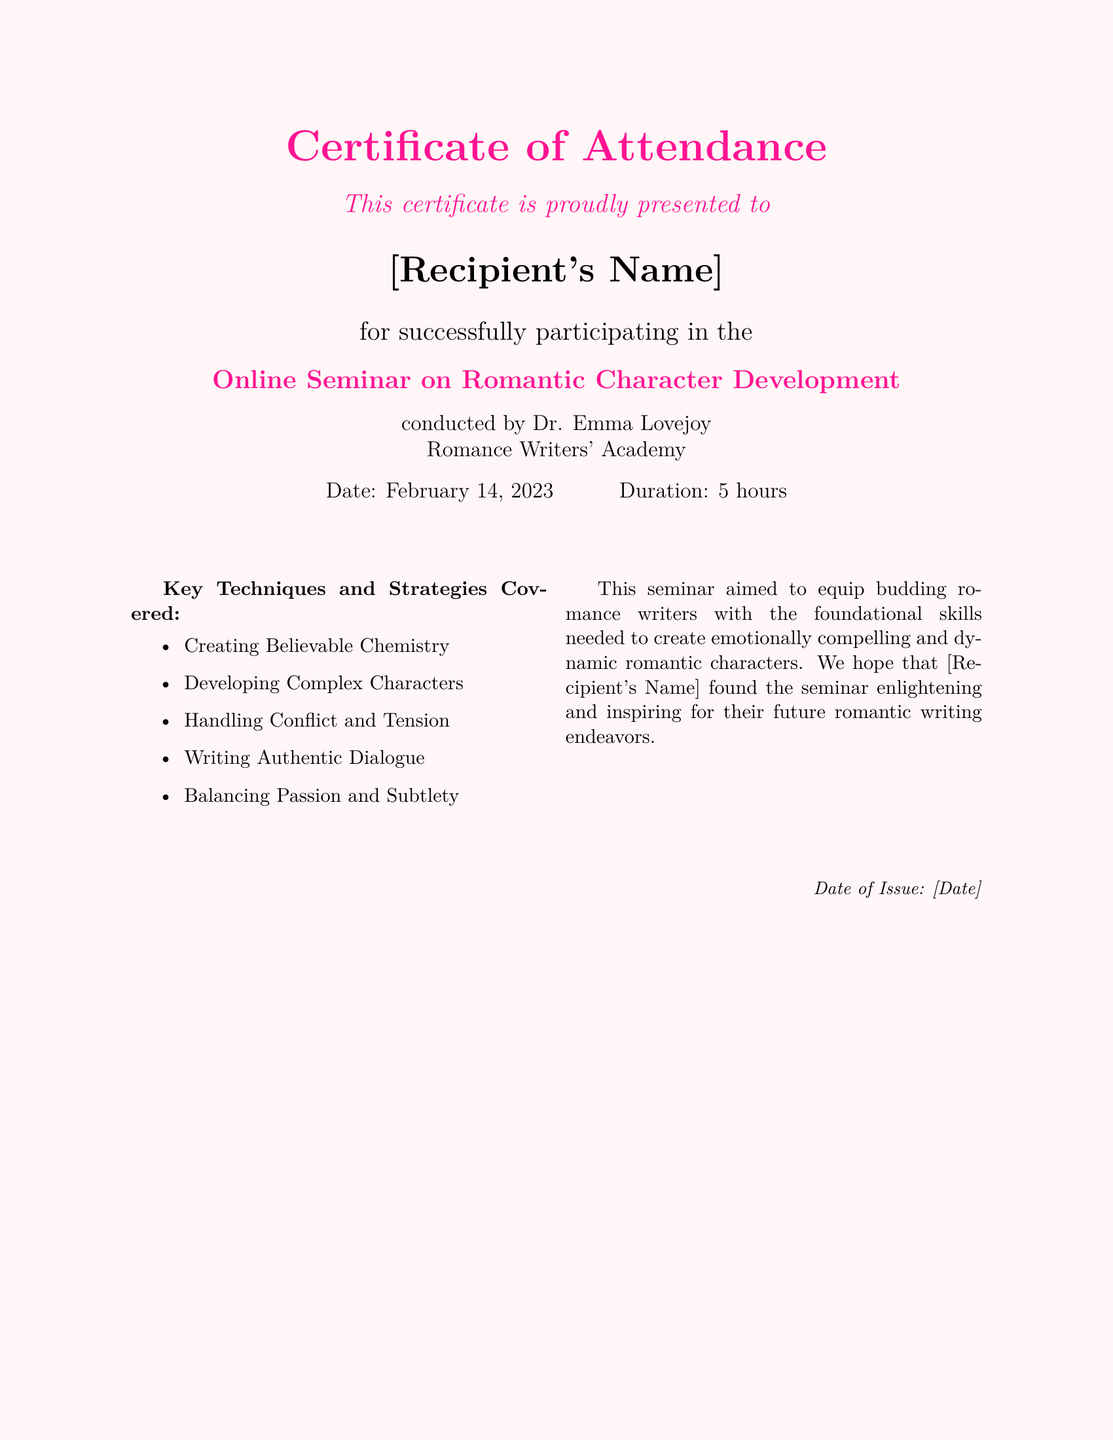What is the name of the seminar? The seminar's title is explicitly stated in the document as "Online Seminar on Romantic Character Development."
Answer: Online Seminar on Romantic Character Development Who conducted the seminar? The document specifies that the seminar was conducted by Dr. Emma Lovejoy.
Answer: Dr. Emma Lovejoy What is the date of the seminar? The document provides the specific date of the seminar, which is clearly indicated as February 14, 2023.
Answer: February 14, 2023 How long was the seminar? The document mentions that the duration of the seminar was 5 hours.
Answer: 5 hours What is one key technique covered in the seminar? The document lists several techniques, one of which is "Creating Believable Chemistry."
Answer: Creating Believable Chemistry What is the purpose of the seminar? The document states that the seminar aimed to equip budding romance writers with foundational skills.
Answer: To equip budding romance writers with foundational skills On what date was the certificate issued? The certificate has a placeholder for the issuance date, indicated as [Date] in the document.
Answer: [Date] What color is the background of the certificate? The document describes the background color as rose pink.
Answer: rose pink 